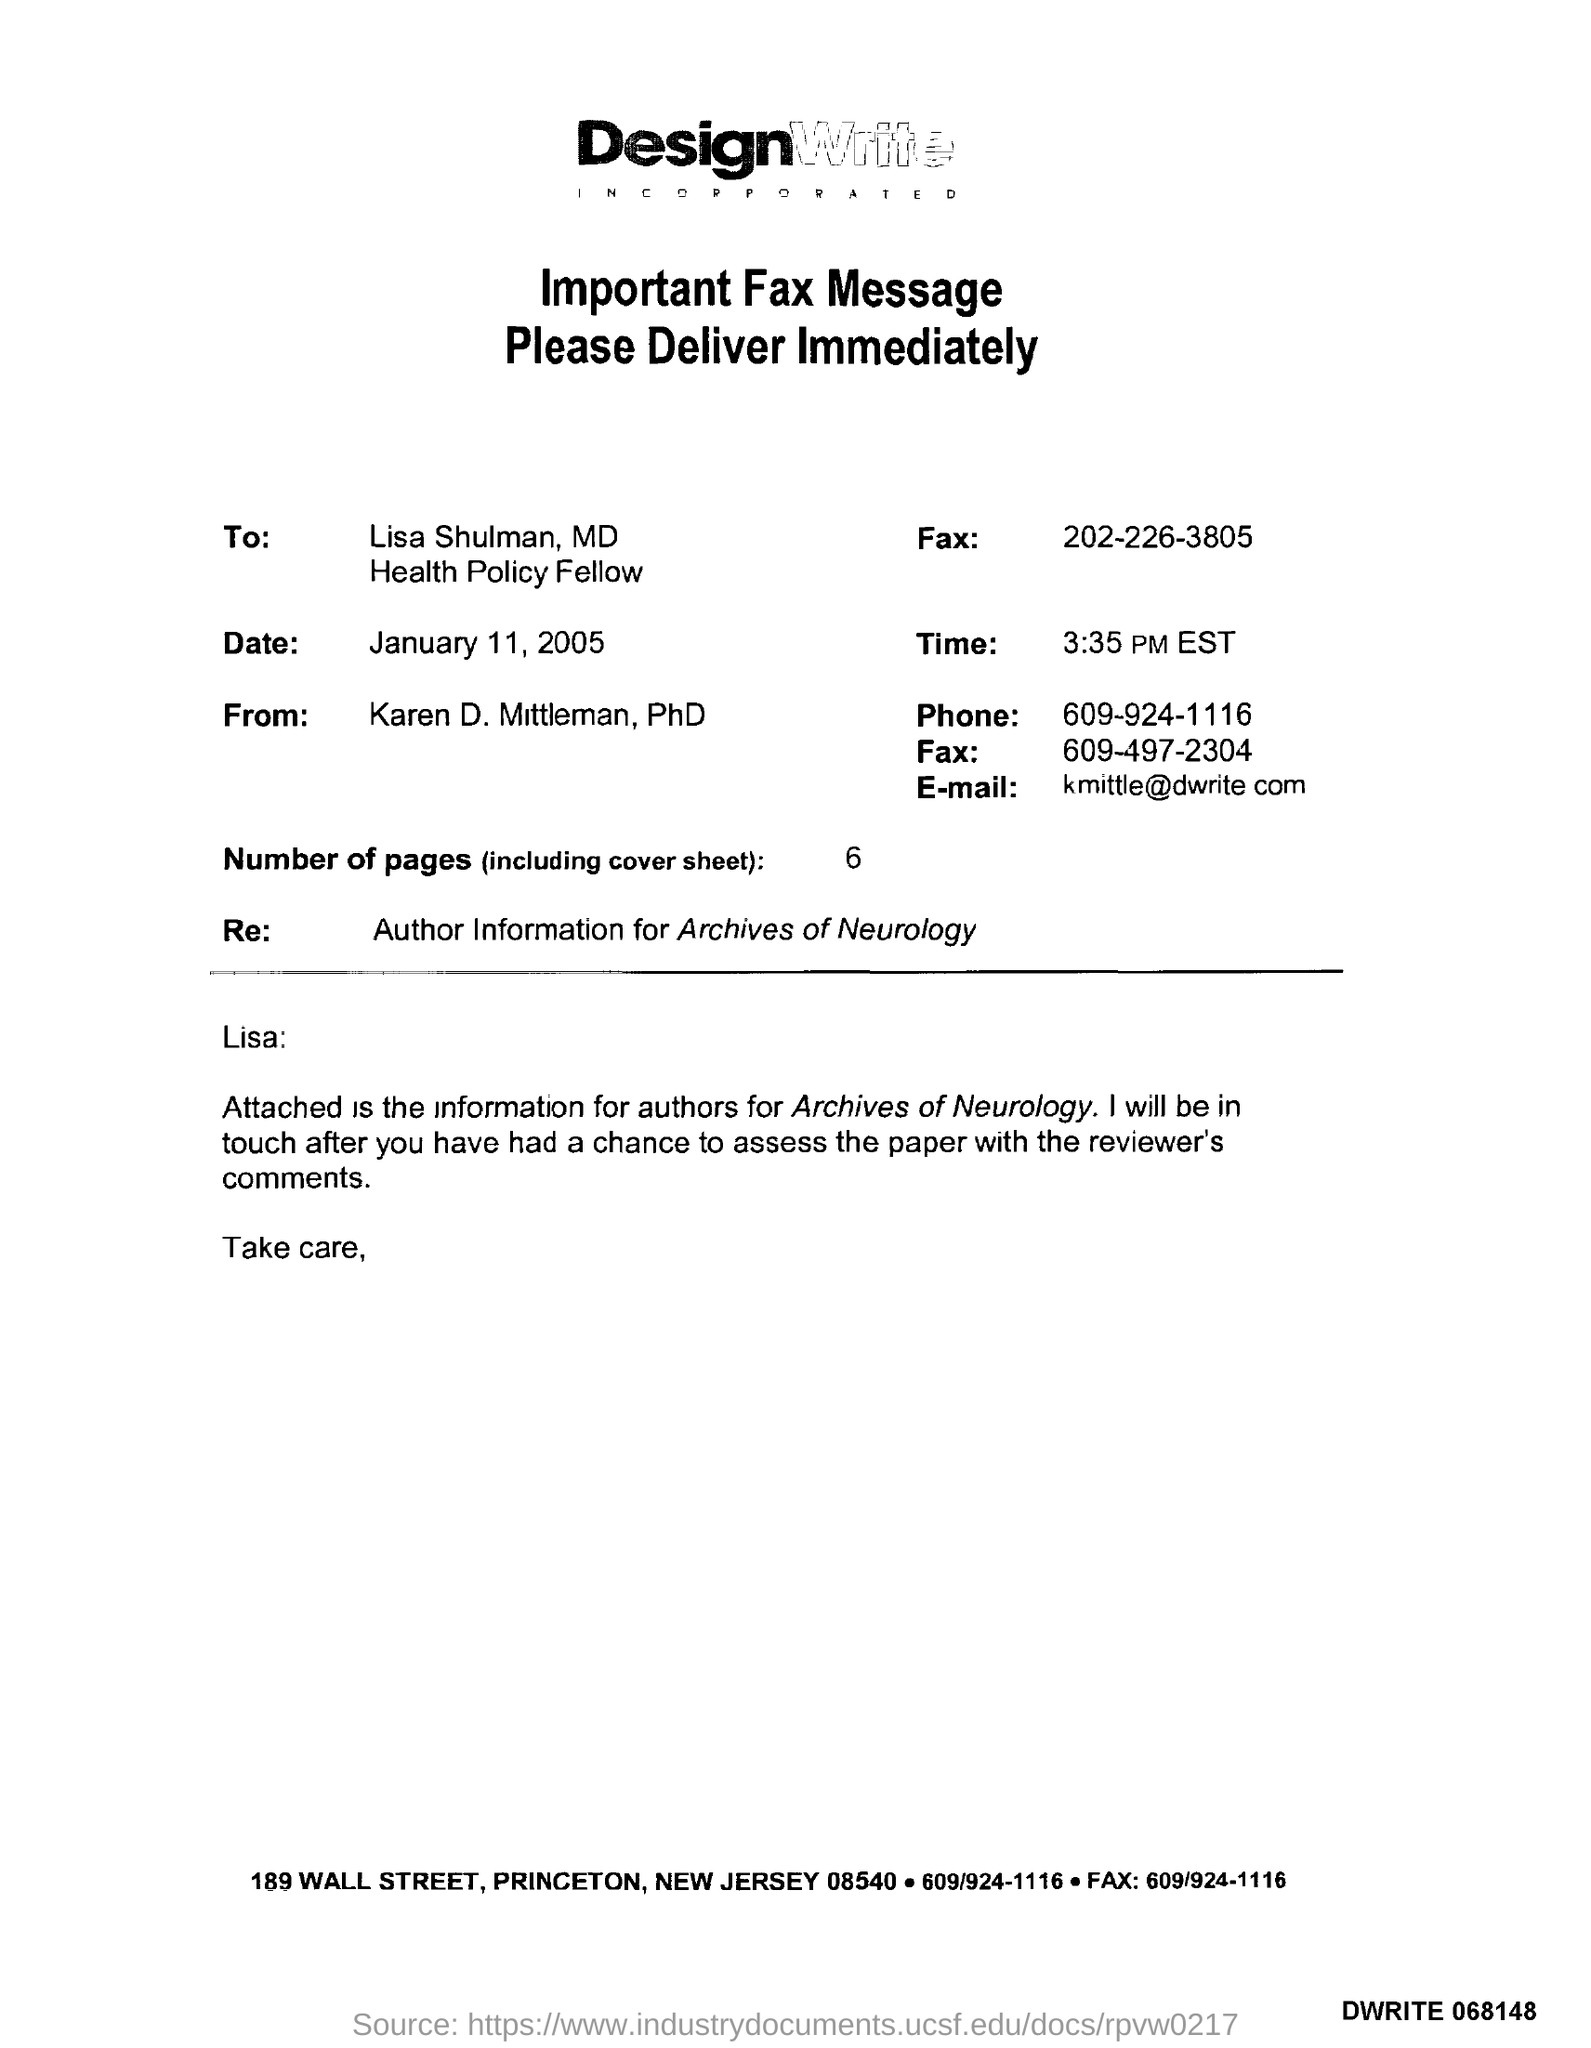Who is the Memorandum addressed to ?
Keep it short and to the point. Lisa Shulman, MD. What is the Receiver Fax Number ?
Ensure brevity in your answer.  202-226-3805. What is the date mentioned in this document ?
Provide a short and direct response. January 11, 2005. What is the Sender Fax Number ?
Ensure brevity in your answer.  609-497-2304. Who is the Memorandum from ?
Provide a short and direct response. Karen D. Mittleman, PhD. How many pages are there?
Provide a succinct answer. 6. What is the Sender Phone Number ?
Provide a short and direct response. 609-924-1116. What is written in the "Re" field ?
Offer a very short reply. Author Information for Archives of Neurology. 